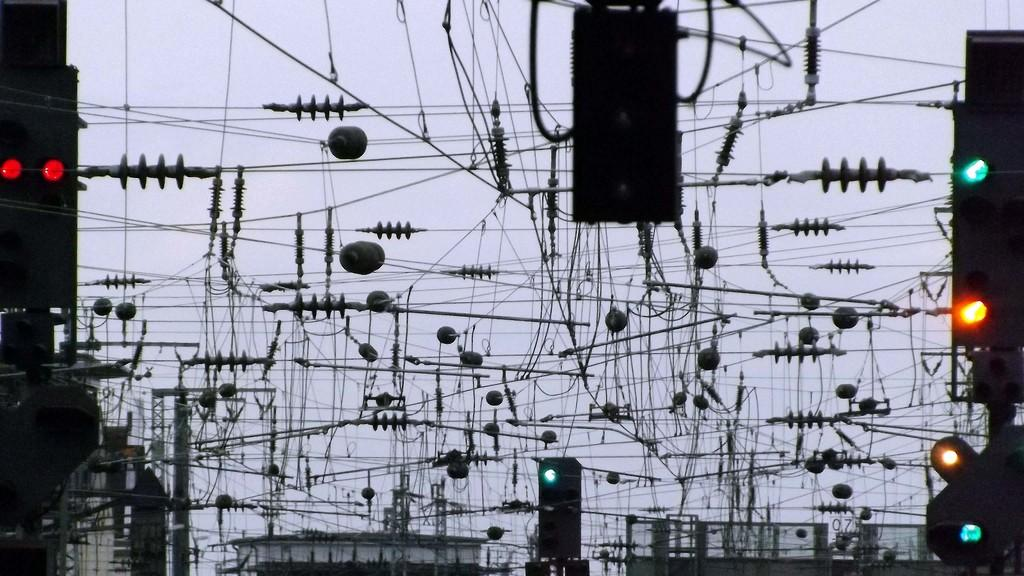What type of infrastructure can be seen in the image? There are traffic signals and buildings in the image. What other objects are present in the image? There are rods and wires in the image. What can be seen in the background of the image? The sky is visible in the background of the image. Where is the yak grazing in the image? There is no yak present in the image. How does the image change when viewed from a different angle? The image itself does not change when viewed from a different angle; it remains the same. 